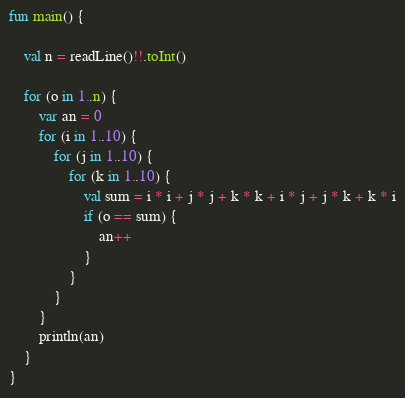<code> <loc_0><loc_0><loc_500><loc_500><_Kotlin_>fun main() {

    val n = readLine()!!.toInt()

    for (o in 1..n) {
        var an = 0
        for (i in 1..10) {
            for (j in 1..10) {
                for (k in 1..10) {
                    val sum = i * i + j * j + k * k + i * j + j * k + k * i
                    if (o == sum) {
                        an++
                    }
                }
            }
        }
        println(an)
    }
}</code> 